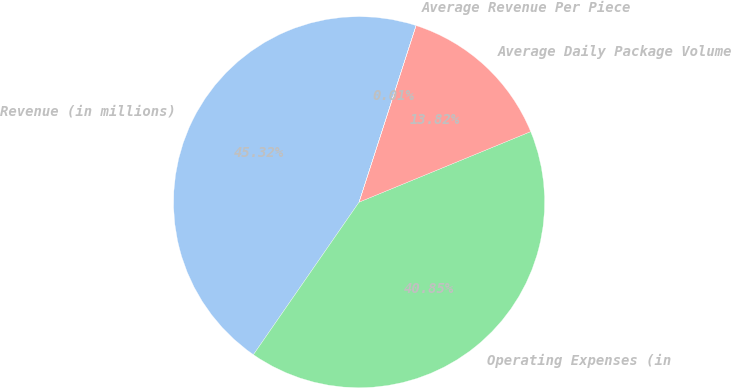<chart> <loc_0><loc_0><loc_500><loc_500><pie_chart><fcel>Revenue (in millions)<fcel>Operating Expenses (in<fcel>Average Daily Package Volume<fcel>Average Revenue Per Piece<nl><fcel>45.32%<fcel>40.85%<fcel>13.82%<fcel>0.01%<nl></chart> 